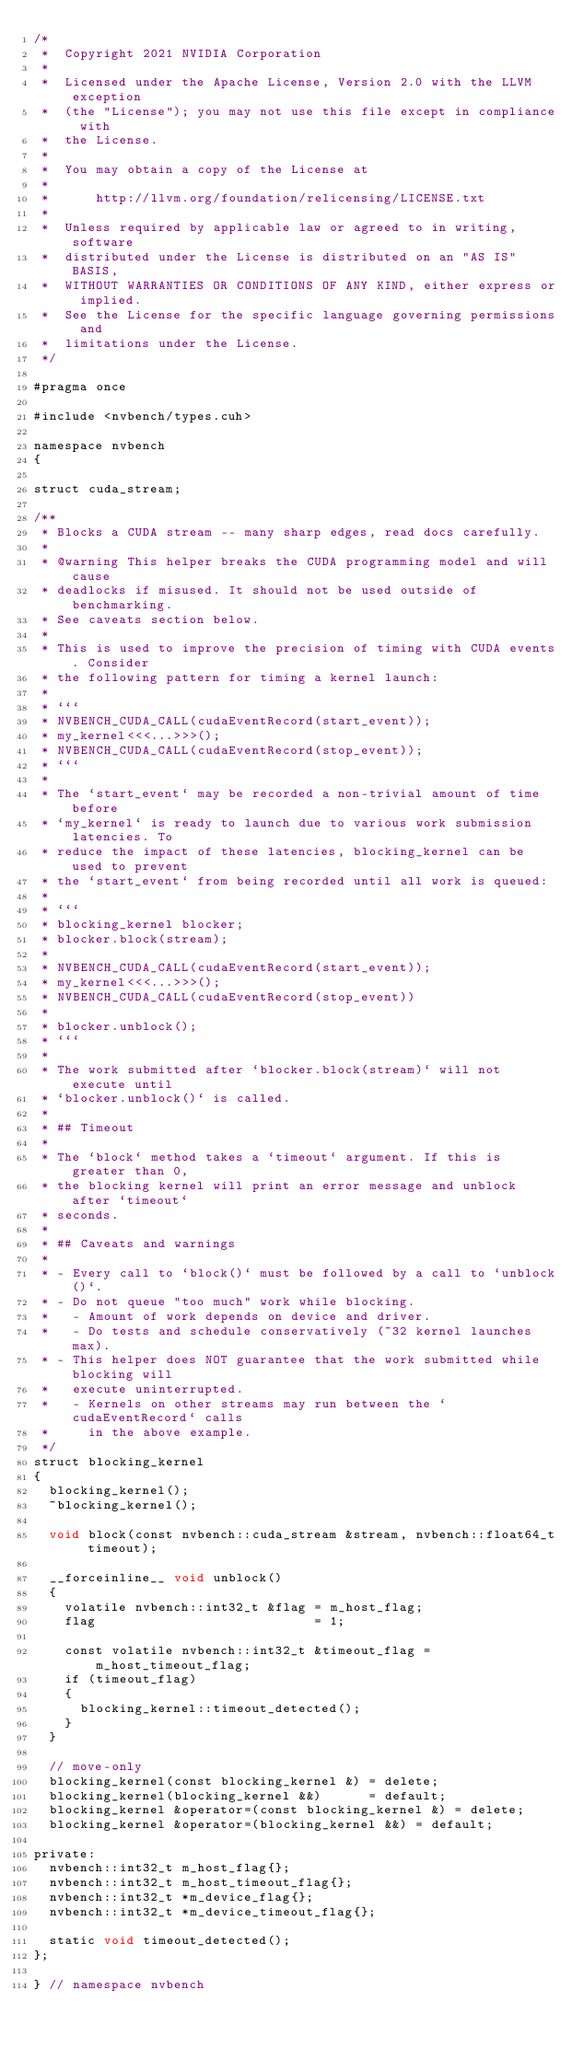<code> <loc_0><loc_0><loc_500><loc_500><_Cuda_>/*
 *  Copyright 2021 NVIDIA Corporation
 *
 *  Licensed under the Apache License, Version 2.0 with the LLVM exception
 *  (the "License"); you may not use this file except in compliance with
 *  the License.
 *
 *  You may obtain a copy of the License at
 *
 *      http://llvm.org/foundation/relicensing/LICENSE.txt
 *
 *  Unless required by applicable law or agreed to in writing, software
 *  distributed under the License is distributed on an "AS IS" BASIS,
 *  WITHOUT WARRANTIES OR CONDITIONS OF ANY KIND, either express or implied.
 *  See the License for the specific language governing permissions and
 *  limitations under the License.
 */

#pragma once

#include <nvbench/types.cuh>

namespace nvbench
{

struct cuda_stream;

/**
 * Blocks a CUDA stream -- many sharp edges, read docs carefully.
 *
 * @warning This helper breaks the CUDA programming model and will cause
 * deadlocks if misused. It should not be used outside of benchmarking.
 * See caveats section below.
 *
 * This is used to improve the precision of timing with CUDA events. Consider
 * the following pattern for timing a kernel launch:
 *
 * ```
 * NVBENCH_CUDA_CALL(cudaEventRecord(start_event));
 * my_kernel<<<...>>>();
 * NVBENCH_CUDA_CALL(cudaEventRecord(stop_event));
 * ```
 *
 * The `start_event` may be recorded a non-trivial amount of time before
 * `my_kernel` is ready to launch due to various work submission latencies. To
 * reduce the impact of these latencies, blocking_kernel can be used to prevent
 * the `start_event` from being recorded until all work is queued:
 *
 * ```
 * blocking_kernel blocker;
 * blocker.block(stream);
 *
 * NVBENCH_CUDA_CALL(cudaEventRecord(start_event));
 * my_kernel<<<...>>>();
 * NVBENCH_CUDA_CALL(cudaEventRecord(stop_event))
 *
 * blocker.unblock();
 * ```
 *
 * The work submitted after `blocker.block(stream)` will not execute until
 * `blocker.unblock()` is called.
 *
 * ## Timeout
 *
 * The `block` method takes a `timeout` argument. If this is greater than 0,
 * the blocking kernel will print an error message and unblock after `timeout`
 * seconds.
 *
 * ## Caveats and warnings
 *
 * - Every call to `block()` must be followed by a call to `unblock()`.
 * - Do not queue "too much" work while blocking.
 *   - Amount of work depends on device and driver.
 *   - Do tests and schedule conservatively (~32 kernel launches max).
 * - This helper does NOT guarantee that the work submitted while blocking will
 *   execute uninterrupted.
 *   - Kernels on other streams may run between the `cudaEventRecord` calls
 *     in the above example.
 */
struct blocking_kernel
{
  blocking_kernel();
  ~blocking_kernel();

  void block(const nvbench::cuda_stream &stream, nvbench::float64_t timeout);

  __forceinline__ void unblock()
  {
    volatile nvbench::int32_t &flag = m_host_flag;
    flag                            = 1;

    const volatile nvbench::int32_t &timeout_flag = m_host_timeout_flag;
    if (timeout_flag)
    {
      blocking_kernel::timeout_detected();
    }
  }

  // move-only
  blocking_kernel(const blocking_kernel &) = delete;
  blocking_kernel(blocking_kernel &&)      = default;
  blocking_kernel &operator=(const blocking_kernel &) = delete;
  blocking_kernel &operator=(blocking_kernel &&) = default;

private:
  nvbench::int32_t m_host_flag{};
  nvbench::int32_t m_host_timeout_flag{};
  nvbench::int32_t *m_device_flag{};
  nvbench::int32_t *m_device_timeout_flag{};

  static void timeout_detected();
};

} // namespace nvbench
</code> 